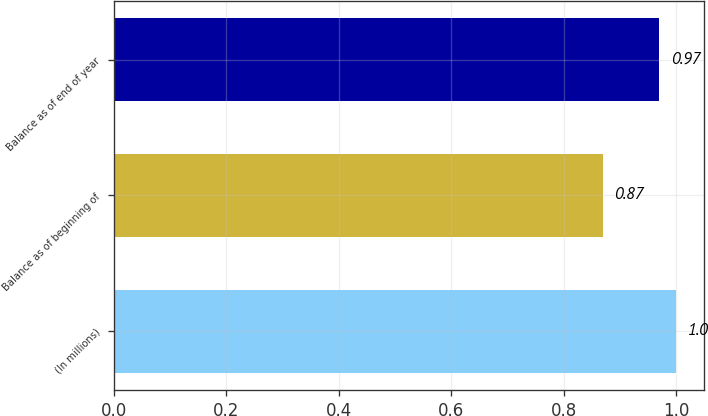<chart> <loc_0><loc_0><loc_500><loc_500><bar_chart><fcel>(In millions)<fcel>Balance as of beginning of<fcel>Balance as of end of year<nl><fcel>1<fcel>0.87<fcel>0.97<nl></chart> 